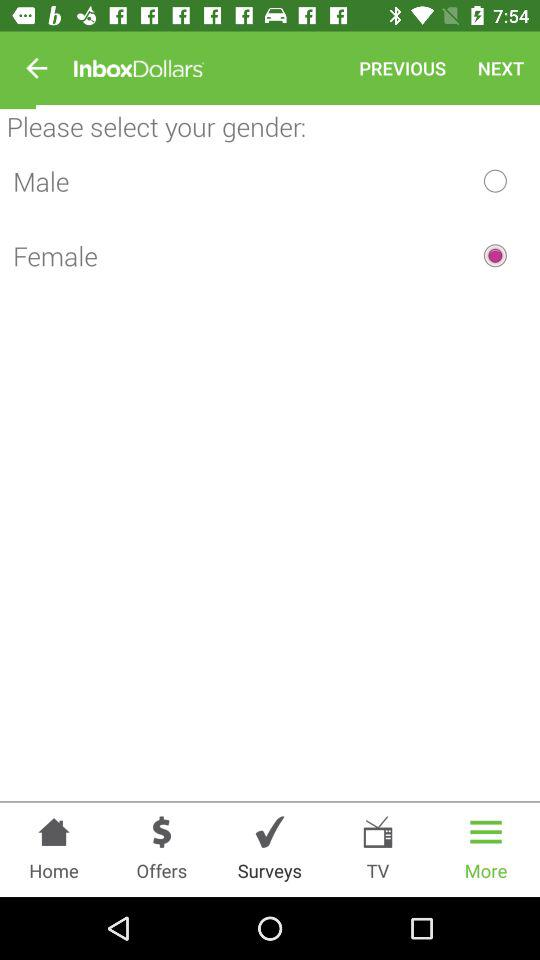What gender is selected? The selected gender is female. 